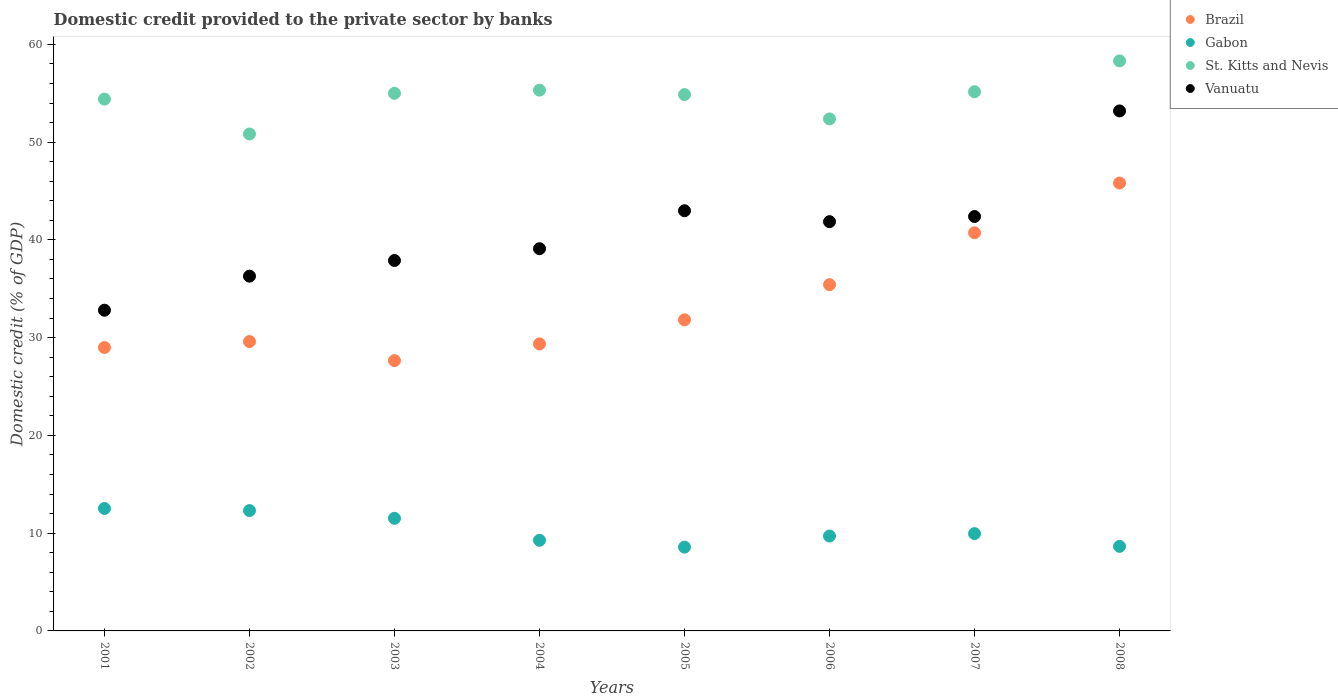How many different coloured dotlines are there?
Your answer should be very brief. 4. What is the domestic credit provided to the private sector by banks in Gabon in 2005?
Offer a very short reply. 8.57. Across all years, what is the maximum domestic credit provided to the private sector by banks in St. Kitts and Nevis?
Your answer should be very brief. 58.31. Across all years, what is the minimum domestic credit provided to the private sector by banks in Vanuatu?
Provide a succinct answer. 32.8. In which year was the domestic credit provided to the private sector by banks in Brazil maximum?
Provide a short and direct response. 2008. What is the total domestic credit provided to the private sector by banks in St. Kitts and Nevis in the graph?
Ensure brevity in your answer.  436.24. What is the difference between the domestic credit provided to the private sector by banks in St. Kitts and Nevis in 2002 and that in 2007?
Give a very brief answer. -4.32. What is the difference between the domestic credit provided to the private sector by banks in Brazil in 2003 and the domestic credit provided to the private sector by banks in St. Kitts and Nevis in 2005?
Your answer should be very brief. -27.21. What is the average domestic credit provided to the private sector by banks in Brazil per year?
Ensure brevity in your answer.  33.67. In the year 2002, what is the difference between the domestic credit provided to the private sector by banks in St. Kitts and Nevis and domestic credit provided to the private sector by banks in Vanuatu?
Provide a succinct answer. 14.54. In how many years, is the domestic credit provided to the private sector by banks in Gabon greater than 2 %?
Your answer should be compact. 8. What is the ratio of the domestic credit provided to the private sector by banks in St. Kitts and Nevis in 2002 to that in 2005?
Offer a very short reply. 0.93. Is the domestic credit provided to the private sector by banks in Vanuatu in 2001 less than that in 2008?
Your answer should be compact. Yes. Is the difference between the domestic credit provided to the private sector by banks in St. Kitts and Nevis in 2005 and 2006 greater than the difference between the domestic credit provided to the private sector by banks in Vanuatu in 2005 and 2006?
Your answer should be compact. Yes. What is the difference between the highest and the second highest domestic credit provided to the private sector by banks in St. Kitts and Nevis?
Make the answer very short. 2.99. What is the difference between the highest and the lowest domestic credit provided to the private sector by banks in Brazil?
Give a very brief answer. 18.16. Is the sum of the domestic credit provided to the private sector by banks in St. Kitts and Nevis in 2005 and 2007 greater than the maximum domestic credit provided to the private sector by banks in Gabon across all years?
Offer a very short reply. Yes. Is the domestic credit provided to the private sector by banks in St. Kitts and Nevis strictly less than the domestic credit provided to the private sector by banks in Gabon over the years?
Your answer should be very brief. No. How many years are there in the graph?
Your answer should be very brief. 8. Does the graph contain grids?
Ensure brevity in your answer.  No. Where does the legend appear in the graph?
Provide a succinct answer. Top right. What is the title of the graph?
Your answer should be compact. Domestic credit provided to the private sector by banks. Does "Senegal" appear as one of the legend labels in the graph?
Your response must be concise. No. What is the label or title of the X-axis?
Provide a succinct answer. Years. What is the label or title of the Y-axis?
Keep it short and to the point. Domestic credit (% of GDP). What is the Domestic credit (% of GDP) in Brazil in 2001?
Keep it short and to the point. 28.99. What is the Domestic credit (% of GDP) of Gabon in 2001?
Your response must be concise. 12.52. What is the Domestic credit (% of GDP) in St. Kitts and Nevis in 2001?
Make the answer very short. 54.4. What is the Domestic credit (% of GDP) of Vanuatu in 2001?
Your answer should be compact. 32.8. What is the Domestic credit (% of GDP) of Brazil in 2002?
Your answer should be compact. 29.6. What is the Domestic credit (% of GDP) of Gabon in 2002?
Your answer should be compact. 12.31. What is the Domestic credit (% of GDP) of St. Kitts and Nevis in 2002?
Offer a very short reply. 50.83. What is the Domestic credit (% of GDP) in Vanuatu in 2002?
Keep it short and to the point. 36.29. What is the Domestic credit (% of GDP) of Brazil in 2003?
Your response must be concise. 27.65. What is the Domestic credit (% of GDP) of Gabon in 2003?
Give a very brief answer. 11.52. What is the Domestic credit (% of GDP) in St. Kitts and Nevis in 2003?
Your response must be concise. 54.99. What is the Domestic credit (% of GDP) in Vanuatu in 2003?
Provide a short and direct response. 37.89. What is the Domestic credit (% of GDP) in Brazil in 2004?
Give a very brief answer. 29.36. What is the Domestic credit (% of GDP) in Gabon in 2004?
Keep it short and to the point. 9.27. What is the Domestic credit (% of GDP) in St. Kitts and Nevis in 2004?
Your response must be concise. 55.32. What is the Domestic credit (% of GDP) of Vanuatu in 2004?
Make the answer very short. 39.1. What is the Domestic credit (% of GDP) of Brazil in 2005?
Keep it short and to the point. 31.82. What is the Domestic credit (% of GDP) of Gabon in 2005?
Your answer should be compact. 8.57. What is the Domestic credit (% of GDP) of St. Kitts and Nevis in 2005?
Provide a short and direct response. 54.86. What is the Domestic credit (% of GDP) of Vanuatu in 2005?
Keep it short and to the point. 42.98. What is the Domestic credit (% of GDP) in Brazil in 2006?
Your response must be concise. 35.42. What is the Domestic credit (% of GDP) of Gabon in 2006?
Give a very brief answer. 9.71. What is the Domestic credit (% of GDP) in St. Kitts and Nevis in 2006?
Your answer should be compact. 52.38. What is the Domestic credit (% of GDP) in Vanuatu in 2006?
Offer a very short reply. 41.86. What is the Domestic credit (% of GDP) in Brazil in 2007?
Give a very brief answer. 40.72. What is the Domestic credit (% of GDP) of Gabon in 2007?
Provide a short and direct response. 9.95. What is the Domestic credit (% of GDP) in St. Kitts and Nevis in 2007?
Make the answer very short. 55.15. What is the Domestic credit (% of GDP) in Vanuatu in 2007?
Provide a short and direct response. 42.39. What is the Domestic credit (% of GDP) of Brazil in 2008?
Your answer should be compact. 45.82. What is the Domestic credit (% of GDP) of Gabon in 2008?
Offer a terse response. 8.65. What is the Domestic credit (% of GDP) of St. Kitts and Nevis in 2008?
Your response must be concise. 58.31. What is the Domestic credit (% of GDP) in Vanuatu in 2008?
Your response must be concise. 53.19. Across all years, what is the maximum Domestic credit (% of GDP) of Brazil?
Provide a short and direct response. 45.82. Across all years, what is the maximum Domestic credit (% of GDP) of Gabon?
Offer a terse response. 12.52. Across all years, what is the maximum Domestic credit (% of GDP) in St. Kitts and Nevis?
Keep it short and to the point. 58.31. Across all years, what is the maximum Domestic credit (% of GDP) of Vanuatu?
Your answer should be compact. 53.19. Across all years, what is the minimum Domestic credit (% of GDP) in Brazil?
Offer a terse response. 27.65. Across all years, what is the minimum Domestic credit (% of GDP) in Gabon?
Keep it short and to the point. 8.57. Across all years, what is the minimum Domestic credit (% of GDP) in St. Kitts and Nevis?
Ensure brevity in your answer.  50.83. Across all years, what is the minimum Domestic credit (% of GDP) in Vanuatu?
Keep it short and to the point. 32.8. What is the total Domestic credit (% of GDP) of Brazil in the graph?
Provide a succinct answer. 269.38. What is the total Domestic credit (% of GDP) in Gabon in the graph?
Provide a short and direct response. 82.5. What is the total Domestic credit (% of GDP) of St. Kitts and Nevis in the graph?
Provide a short and direct response. 436.24. What is the total Domestic credit (% of GDP) of Vanuatu in the graph?
Give a very brief answer. 326.5. What is the difference between the Domestic credit (% of GDP) of Brazil in 2001 and that in 2002?
Your response must be concise. -0.61. What is the difference between the Domestic credit (% of GDP) in Gabon in 2001 and that in 2002?
Make the answer very short. 0.21. What is the difference between the Domestic credit (% of GDP) of St. Kitts and Nevis in 2001 and that in 2002?
Your answer should be very brief. 3.57. What is the difference between the Domestic credit (% of GDP) in Vanuatu in 2001 and that in 2002?
Make the answer very short. -3.48. What is the difference between the Domestic credit (% of GDP) in Brazil in 2001 and that in 2003?
Offer a very short reply. 1.34. What is the difference between the Domestic credit (% of GDP) of Gabon in 2001 and that in 2003?
Ensure brevity in your answer.  1. What is the difference between the Domestic credit (% of GDP) in St. Kitts and Nevis in 2001 and that in 2003?
Ensure brevity in your answer.  -0.6. What is the difference between the Domestic credit (% of GDP) of Vanuatu in 2001 and that in 2003?
Offer a very short reply. -5.08. What is the difference between the Domestic credit (% of GDP) in Brazil in 2001 and that in 2004?
Offer a very short reply. -0.37. What is the difference between the Domestic credit (% of GDP) of Gabon in 2001 and that in 2004?
Your response must be concise. 3.25. What is the difference between the Domestic credit (% of GDP) in St. Kitts and Nevis in 2001 and that in 2004?
Provide a short and direct response. -0.92. What is the difference between the Domestic credit (% of GDP) of Vanuatu in 2001 and that in 2004?
Your answer should be compact. -6.29. What is the difference between the Domestic credit (% of GDP) in Brazil in 2001 and that in 2005?
Your answer should be compact. -2.83. What is the difference between the Domestic credit (% of GDP) in Gabon in 2001 and that in 2005?
Keep it short and to the point. 3.95. What is the difference between the Domestic credit (% of GDP) in St. Kitts and Nevis in 2001 and that in 2005?
Provide a short and direct response. -0.47. What is the difference between the Domestic credit (% of GDP) of Vanuatu in 2001 and that in 2005?
Your response must be concise. -10.18. What is the difference between the Domestic credit (% of GDP) of Brazil in 2001 and that in 2006?
Give a very brief answer. -6.43. What is the difference between the Domestic credit (% of GDP) in Gabon in 2001 and that in 2006?
Provide a succinct answer. 2.81. What is the difference between the Domestic credit (% of GDP) in St. Kitts and Nevis in 2001 and that in 2006?
Keep it short and to the point. 2.02. What is the difference between the Domestic credit (% of GDP) of Vanuatu in 2001 and that in 2006?
Your answer should be very brief. -9.06. What is the difference between the Domestic credit (% of GDP) in Brazil in 2001 and that in 2007?
Offer a terse response. -11.73. What is the difference between the Domestic credit (% of GDP) in Gabon in 2001 and that in 2007?
Your answer should be very brief. 2.57. What is the difference between the Domestic credit (% of GDP) in St. Kitts and Nevis in 2001 and that in 2007?
Ensure brevity in your answer.  -0.75. What is the difference between the Domestic credit (% of GDP) of Vanuatu in 2001 and that in 2007?
Provide a short and direct response. -9.59. What is the difference between the Domestic credit (% of GDP) in Brazil in 2001 and that in 2008?
Your response must be concise. -16.82. What is the difference between the Domestic credit (% of GDP) of Gabon in 2001 and that in 2008?
Your answer should be compact. 3.87. What is the difference between the Domestic credit (% of GDP) of St. Kitts and Nevis in 2001 and that in 2008?
Give a very brief answer. -3.91. What is the difference between the Domestic credit (% of GDP) in Vanuatu in 2001 and that in 2008?
Your response must be concise. -20.38. What is the difference between the Domestic credit (% of GDP) of Brazil in 2002 and that in 2003?
Keep it short and to the point. 1.95. What is the difference between the Domestic credit (% of GDP) in Gabon in 2002 and that in 2003?
Ensure brevity in your answer.  0.79. What is the difference between the Domestic credit (% of GDP) in St. Kitts and Nevis in 2002 and that in 2003?
Keep it short and to the point. -4.16. What is the difference between the Domestic credit (% of GDP) of Vanuatu in 2002 and that in 2003?
Make the answer very short. -1.6. What is the difference between the Domestic credit (% of GDP) in Brazil in 2002 and that in 2004?
Give a very brief answer. 0.24. What is the difference between the Domestic credit (% of GDP) in Gabon in 2002 and that in 2004?
Offer a very short reply. 3.04. What is the difference between the Domestic credit (% of GDP) of St. Kitts and Nevis in 2002 and that in 2004?
Your answer should be very brief. -4.49. What is the difference between the Domestic credit (% of GDP) in Vanuatu in 2002 and that in 2004?
Make the answer very short. -2.81. What is the difference between the Domestic credit (% of GDP) in Brazil in 2002 and that in 2005?
Give a very brief answer. -2.23. What is the difference between the Domestic credit (% of GDP) of Gabon in 2002 and that in 2005?
Your answer should be compact. 3.74. What is the difference between the Domestic credit (% of GDP) of St. Kitts and Nevis in 2002 and that in 2005?
Give a very brief answer. -4.03. What is the difference between the Domestic credit (% of GDP) of Vanuatu in 2002 and that in 2005?
Offer a very short reply. -6.69. What is the difference between the Domestic credit (% of GDP) of Brazil in 2002 and that in 2006?
Provide a succinct answer. -5.82. What is the difference between the Domestic credit (% of GDP) in Gabon in 2002 and that in 2006?
Provide a succinct answer. 2.6. What is the difference between the Domestic credit (% of GDP) of St. Kitts and Nevis in 2002 and that in 2006?
Your answer should be very brief. -1.54. What is the difference between the Domestic credit (% of GDP) in Vanuatu in 2002 and that in 2006?
Your answer should be very brief. -5.57. What is the difference between the Domestic credit (% of GDP) of Brazil in 2002 and that in 2007?
Ensure brevity in your answer.  -11.13. What is the difference between the Domestic credit (% of GDP) in Gabon in 2002 and that in 2007?
Keep it short and to the point. 2.36. What is the difference between the Domestic credit (% of GDP) in St. Kitts and Nevis in 2002 and that in 2007?
Provide a succinct answer. -4.32. What is the difference between the Domestic credit (% of GDP) of Vanuatu in 2002 and that in 2007?
Provide a short and direct response. -6.1. What is the difference between the Domestic credit (% of GDP) in Brazil in 2002 and that in 2008?
Provide a succinct answer. -16.22. What is the difference between the Domestic credit (% of GDP) in Gabon in 2002 and that in 2008?
Give a very brief answer. 3.66. What is the difference between the Domestic credit (% of GDP) in St. Kitts and Nevis in 2002 and that in 2008?
Provide a short and direct response. -7.48. What is the difference between the Domestic credit (% of GDP) of Vanuatu in 2002 and that in 2008?
Provide a short and direct response. -16.9. What is the difference between the Domestic credit (% of GDP) of Brazil in 2003 and that in 2004?
Offer a very short reply. -1.71. What is the difference between the Domestic credit (% of GDP) of Gabon in 2003 and that in 2004?
Make the answer very short. 2.25. What is the difference between the Domestic credit (% of GDP) in St. Kitts and Nevis in 2003 and that in 2004?
Make the answer very short. -0.33. What is the difference between the Domestic credit (% of GDP) of Vanuatu in 2003 and that in 2004?
Your response must be concise. -1.21. What is the difference between the Domestic credit (% of GDP) of Brazil in 2003 and that in 2005?
Your response must be concise. -4.17. What is the difference between the Domestic credit (% of GDP) of Gabon in 2003 and that in 2005?
Make the answer very short. 2.95. What is the difference between the Domestic credit (% of GDP) in St. Kitts and Nevis in 2003 and that in 2005?
Provide a short and direct response. 0.13. What is the difference between the Domestic credit (% of GDP) in Vanuatu in 2003 and that in 2005?
Provide a short and direct response. -5.09. What is the difference between the Domestic credit (% of GDP) of Brazil in 2003 and that in 2006?
Keep it short and to the point. -7.77. What is the difference between the Domestic credit (% of GDP) in Gabon in 2003 and that in 2006?
Your answer should be very brief. 1.81. What is the difference between the Domestic credit (% of GDP) in St. Kitts and Nevis in 2003 and that in 2006?
Provide a succinct answer. 2.62. What is the difference between the Domestic credit (% of GDP) in Vanuatu in 2003 and that in 2006?
Your answer should be compact. -3.97. What is the difference between the Domestic credit (% of GDP) of Brazil in 2003 and that in 2007?
Your answer should be very brief. -13.07. What is the difference between the Domestic credit (% of GDP) in Gabon in 2003 and that in 2007?
Offer a terse response. 1.57. What is the difference between the Domestic credit (% of GDP) of St. Kitts and Nevis in 2003 and that in 2007?
Provide a short and direct response. -0.16. What is the difference between the Domestic credit (% of GDP) of Vanuatu in 2003 and that in 2007?
Your answer should be compact. -4.5. What is the difference between the Domestic credit (% of GDP) in Brazil in 2003 and that in 2008?
Provide a succinct answer. -18.16. What is the difference between the Domestic credit (% of GDP) in Gabon in 2003 and that in 2008?
Give a very brief answer. 2.87. What is the difference between the Domestic credit (% of GDP) of St. Kitts and Nevis in 2003 and that in 2008?
Provide a succinct answer. -3.32. What is the difference between the Domestic credit (% of GDP) in Vanuatu in 2003 and that in 2008?
Provide a short and direct response. -15.3. What is the difference between the Domestic credit (% of GDP) in Brazil in 2004 and that in 2005?
Offer a terse response. -2.46. What is the difference between the Domestic credit (% of GDP) in Gabon in 2004 and that in 2005?
Your answer should be compact. 0.7. What is the difference between the Domestic credit (% of GDP) of St. Kitts and Nevis in 2004 and that in 2005?
Ensure brevity in your answer.  0.45. What is the difference between the Domestic credit (% of GDP) in Vanuatu in 2004 and that in 2005?
Your answer should be compact. -3.88. What is the difference between the Domestic credit (% of GDP) in Brazil in 2004 and that in 2006?
Make the answer very short. -6.06. What is the difference between the Domestic credit (% of GDP) of Gabon in 2004 and that in 2006?
Give a very brief answer. -0.44. What is the difference between the Domestic credit (% of GDP) of St. Kitts and Nevis in 2004 and that in 2006?
Keep it short and to the point. 2.94. What is the difference between the Domestic credit (% of GDP) of Vanuatu in 2004 and that in 2006?
Make the answer very short. -2.77. What is the difference between the Domestic credit (% of GDP) in Brazil in 2004 and that in 2007?
Give a very brief answer. -11.37. What is the difference between the Domestic credit (% of GDP) of Gabon in 2004 and that in 2007?
Your answer should be very brief. -0.68. What is the difference between the Domestic credit (% of GDP) of St. Kitts and Nevis in 2004 and that in 2007?
Ensure brevity in your answer.  0.17. What is the difference between the Domestic credit (% of GDP) in Vanuatu in 2004 and that in 2007?
Provide a short and direct response. -3.29. What is the difference between the Domestic credit (% of GDP) in Brazil in 2004 and that in 2008?
Your answer should be compact. -16.46. What is the difference between the Domestic credit (% of GDP) of Gabon in 2004 and that in 2008?
Make the answer very short. 0.62. What is the difference between the Domestic credit (% of GDP) of St. Kitts and Nevis in 2004 and that in 2008?
Ensure brevity in your answer.  -2.99. What is the difference between the Domestic credit (% of GDP) in Vanuatu in 2004 and that in 2008?
Provide a short and direct response. -14.09. What is the difference between the Domestic credit (% of GDP) in Brazil in 2005 and that in 2006?
Provide a succinct answer. -3.6. What is the difference between the Domestic credit (% of GDP) in Gabon in 2005 and that in 2006?
Give a very brief answer. -1.14. What is the difference between the Domestic credit (% of GDP) in St. Kitts and Nevis in 2005 and that in 2006?
Your answer should be compact. 2.49. What is the difference between the Domestic credit (% of GDP) of Vanuatu in 2005 and that in 2006?
Your answer should be very brief. 1.12. What is the difference between the Domestic credit (% of GDP) in Brazil in 2005 and that in 2007?
Make the answer very short. -8.9. What is the difference between the Domestic credit (% of GDP) in Gabon in 2005 and that in 2007?
Offer a terse response. -1.38. What is the difference between the Domestic credit (% of GDP) of St. Kitts and Nevis in 2005 and that in 2007?
Your answer should be very brief. -0.29. What is the difference between the Domestic credit (% of GDP) of Vanuatu in 2005 and that in 2007?
Make the answer very short. 0.59. What is the difference between the Domestic credit (% of GDP) of Brazil in 2005 and that in 2008?
Give a very brief answer. -13.99. What is the difference between the Domestic credit (% of GDP) in Gabon in 2005 and that in 2008?
Ensure brevity in your answer.  -0.08. What is the difference between the Domestic credit (% of GDP) of St. Kitts and Nevis in 2005 and that in 2008?
Make the answer very short. -3.44. What is the difference between the Domestic credit (% of GDP) in Vanuatu in 2005 and that in 2008?
Make the answer very short. -10.21. What is the difference between the Domestic credit (% of GDP) in Brazil in 2006 and that in 2007?
Your answer should be compact. -5.3. What is the difference between the Domestic credit (% of GDP) of Gabon in 2006 and that in 2007?
Offer a terse response. -0.24. What is the difference between the Domestic credit (% of GDP) of St. Kitts and Nevis in 2006 and that in 2007?
Your answer should be compact. -2.77. What is the difference between the Domestic credit (% of GDP) of Vanuatu in 2006 and that in 2007?
Give a very brief answer. -0.53. What is the difference between the Domestic credit (% of GDP) in Brazil in 2006 and that in 2008?
Offer a very short reply. -10.4. What is the difference between the Domestic credit (% of GDP) of Gabon in 2006 and that in 2008?
Your response must be concise. 1.06. What is the difference between the Domestic credit (% of GDP) in St. Kitts and Nevis in 2006 and that in 2008?
Your answer should be very brief. -5.93. What is the difference between the Domestic credit (% of GDP) in Vanuatu in 2006 and that in 2008?
Make the answer very short. -11.33. What is the difference between the Domestic credit (% of GDP) in Brazil in 2007 and that in 2008?
Provide a short and direct response. -5.09. What is the difference between the Domestic credit (% of GDP) of Gabon in 2007 and that in 2008?
Offer a very short reply. 1.3. What is the difference between the Domestic credit (% of GDP) in St. Kitts and Nevis in 2007 and that in 2008?
Your answer should be very brief. -3.16. What is the difference between the Domestic credit (% of GDP) in Vanuatu in 2007 and that in 2008?
Offer a very short reply. -10.8. What is the difference between the Domestic credit (% of GDP) of Brazil in 2001 and the Domestic credit (% of GDP) of Gabon in 2002?
Offer a very short reply. 16.68. What is the difference between the Domestic credit (% of GDP) of Brazil in 2001 and the Domestic credit (% of GDP) of St. Kitts and Nevis in 2002?
Offer a very short reply. -21.84. What is the difference between the Domestic credit (% of GDP) of Brazil in 2001 and the Domestic credit (% of GDP) of Vanuatu in 2002?
Your response must be concise. -7.3. What is the difference between the Domestic credit (% of GDP) of Gabon in 2001 and the Domestic credit (% of GDP) of St. Kitts and Nevis in 2002?
Provide a short and direct response. -38.31. What is the difference between the Domestic credit (% of GDP) of Gabon in 2001 and the Domestic credit (% of GDP) of Vanuatu in 2002?
Your answer should be very brief. -23.77. What is the difference between the Domestic credit (% of GDP) in St. Kitts and Nevis in 2001 and the Domestic credit (% of GDP) in Vanuatu in 2002?
Provide a short and direct response. 18.11. What is the difference between the Domestic credit (% of GDP) in Brazil in 2001 and the Domestic credit (% of GDP) in Gabon in 2003?
Your answer should be very brief. 17.47. What is the difference between the Domestic credit (% of GDP) of Brazil in 2001 and the Domestic credit (% of GDP) of St. Kitts and Nevis in 2003?
Your response must be concise. -26. What is the difference between the Domestic credit (% of GDP) of Brazil in 2001 and the Domestic credit (% of GDP) of Vanuatu in 2003?
Your response must be concise. -8.9. What is the difference between the Domestic credit (% of GDP) in Gabon in 2001 and the Domestic credit (% of GDP) in St. Kitts and Nevis in 2003?
Your response must be concise. -42.47. What is the difference between the Domestic credit (% of GDP) of Gabon in 2001 and the Domestic credit (% of GDP) of Vanuatu in 2003?
Ensure brevity in your answer.  -25.37. What is the difference between the Domestic credit (% of GDP) of St. Kitts and Nevis in 2001 and the Domestic credit (% of GDP) of Vanuatu in 2003?
Make the answer very short. 16.51. What is the difference between the Domestic credit (% of GDP) of Brazil in 2001 and the Domestic credit (% of GDP) of Gabon in 2004?
Make the answer very short. 19.72. What is the difference between the Domestic credit (% of GDP) of Brazil in 2001 and the Domestic credit (% of GDP) of St. Kitts and Nevis in 2004?
Your response must be concise. -26.33. What is the difference between the Domestic credit (% of GDP) of Brazil in 2001 and the Domestic credit (% of GDP) of Vanuatu in 2004?
Provide a short and direct response. -10.11. What is the difference between the Domestic credit (% of GDP) of Gabon in 2001 and the Domestic credit (% of GDP) of St. Kitts and Nevis in 2004?
Keep it short and to the point. -42.8. What is the difference between the Domestic credit (% of GDP) in Gabon in 2001 and the Domestic credit (% of GDP) in Vanuatu in 2004?
Give a very brief answer. -26.58. What is the difference between the Domestic credit (% of GDP) of St. Kitts and Nevis in 2001 and the Domestic credit (% of GDP) of Vanuatu in 2004?
Ensure brevity in your answer.  15.3. What is the difference between the Domestic credit (% of GDP) of Brazil in 2001 and the Domestic credit (% of GDP) of Gabon in 2005?
Keep it short and to the point. 20.42. What is the difference between the Domestic credit (% of GDP) of Brazil in 2001 and the Domestic credit (% of GDP) of St. Kitts and Nevis in 2005?
Ensure brevity in your answer.  -25.87. What is the difference between the Domestic credit (% of GDP) in Brazil in 2001 and the Domestic credit (% of GDP) in Vanuatu in 2005?
Your answer should be very brief. -13.99. What is the difference between the Domestic credit (% of GDP) in Gabon in 2001 and the Domestic credit (% of GDP) in St. Kitts and Nevis in 2005?
Your answer should be very brief. -42.34. What is the difference between the Domestic credit (% of GDP) of Gabon in 2001 and the Domestic credit (% of GDP) of Vanuatu in 2005?
Your answer should be compact. -30.46. What is the difference between the Domestic credit (% of GDP) of St. Kitts and Nevis in 2001 and the Domestic credit (% of GDP) of Vanuatu in 2005?
Your answer should be very brief. 11.42. What is the difference between the Domestic credit (% of GDP) of Brazil in 2001 and the Domestic credit (% of GDP) of Gabon in 2006?
Offer a very short reply. 19.28. What is the difference between the Domestic credit (% of GDP) of Brazil in 2001 and the Domestic credit (% of GDP) of St. Kitts and Nevis in 2006?
Offer a very short reply. -23.38. What is the difference between the Domestic credit (% of GDP) of Brazil in 2001 and the Domestic credit (% of GDP) of Vanuatu in 2006?
Make the answer very short. -12.87. What is the difference between the Domestic credit (% of GDP) in Gabon in 2001 and the Domestic credit (% of GDP) in St. Kitts and Nevis in 2006?
Your response must be concise. -39.85. What is the difference between the Domestic credit (% of GDP) of Gabon in 2001 and the Domestic credit (% of GDP) of Vanuatu in 2006?
Offer a terse response. -29.34. What is the difference between the Domestic credit (% of GDP) in St. Kitts and Nevis in 2001 and the Domestic credit (% of GDP) in Vanuatu in 2006?
Provide a short and direct response. 12.53. What is the difference between the Domestic credit (% of GDP) of Brazil in 2001 and the Domestic credit (% of GDP) of Gabon in 2007?
Give a very brief answer. 19.04. What is the difference between the Domestic credit (% of GDP) in Brazil in 2001 and the Domestic credit (% of GDP) in St. Kitts and Nevis in 2007?
Give a very brief answer. -26.16. What is the difference between the Domestic credit (% of GDP) in Gabon in 2001 and the Domestic credit (% of GDP) in St. Kitts and Nevis in 2007?
Ensure brevity in your answer.  -42.63. What is the difference between the Domestic credit (% of GDP) in Gabon in 2001 and the Domestic credit (% of GDP) in Vanuatu in 2007?
Offer a very short reply. -29.87. What is the difference between the Domestic credit (% of GDP) in St. Kitts and Nevis in 2001 and the Domestic credit (% of GDP) in Vanuatu in 2007?
Your response must be concise. 12.01. What is the difference between the Domestic credit (% of GDP) of Brazil in 2001 and the Domestic credit (% of GDP) of Gabon in 2008?
Offer a very short reply. 20.34. What is the difference between the Domestic credit (% of GDP) in Brazil in 2001 and the Domestic credit (% of GDP) in St. Kitts and Nevis in 2008?
Give a very brief answer. -29.32. What is the difference between the Domestic credit (% of GDP) in Brazil in 2001 and the Domestic credit (% of GDP) in Vanuatu in 2008?
Offer a very short reply. -24.2. What is the difference between the Domestic credit (% of GDP) of Gabon in 2001 and the Domestic credit (% of GDP) of St. Kitts and Nevis in 2008?
Your response must be concise. -45.79. What is the difference between the Domestic credit (% of GDP) in Gabon in 2001 and the Domestic credit (% of GDP) in Vanuatu in 2008?
Make the answer very short. -40.67. What is the difference between the Domestic credit (% of GDP) in St. Kitts and Nevis in 2001 and the Domestic credit (% of GDP) in Vanuatu in 2008?
Offer a terse response. 1.21. What is the difference between the Domestic credit (% of GDP) of Brazil in 2002 and the Domestic credit (% of GDP) of Gabon in 2003?
Make the answer very short. 18.08. What is the difference between the Domestic credit (% of GDP) in Brazil in 2002 and the Domestic credit (% of GDP) in St. Kitts and Nevis in 2003?
Your answer should be compact. -25.4. What is the difference between the Domestic credit (% of GDP) of Brazil in 2002 and the Domestic credit (% of GDP) of Vanuatu in 2003?
Your response must be concise. -8.29. What is the difference between the Domestic credit (% of GDP) of Gabon in 2002 and the Domestic credit (% of GDP) of St. Kitts and Nevis in 2003?
Your answer should be very brief. -42.68. What is the difference between the Domestic credit (% of GDP) in Gabon in 2002 and the Domestic credit (% of GDP) in Vanuatu in 2003?
Make the answer very short. -25.58. What is the difference between the Domestic credit (% of GDP) in St. Kitts and Nevis in 2002 and the Domestic credit (% of GDP) in Vanuatu in 2003?
Your answer should be very brief. 12.94. What is the difference between the Domestic credit (% of GDP) of Brazil in 2002 and the Domestic credit (% of GDP) of Gabon in 2004?
Provide a succinct answer. 20.33. What is the difference between the Domestic credit (% of GDP) in Brazil in 2002 and the Domestic credit (% of GDP) in St. Kitts and Nevis in 2004?
Give a very brief answer. -25.72. What is the difference between the Domestic credit (% of GDP) of Brazil in 2002 and the Domestic credit (% of GDP) of Vanuatu in 2004?
Provide a succinct answer. -9.5. What is the difference between the Domestic credit (% of GDP) in Gabon in 2002 and the Domestic credit (% of GDP) in St. Kitts and Nevis in 2004?
Offer a terse response. -43.01. What is the difference between the Domestic credit (% of GDP) in Gabon in 2002 and the Domestic credit (% of GDP) in Vanuatu in 2004?
Provide a short and direct response. -26.79. What is the difference between the Domestic credit (% of GDP) of St. Kitts and Nevis in 2002 and the Domestic credit (% of GDP) of Vanuatu in 2004?
Your answer should be very brief. 11.73. What is the difference between the Domestic credit (% of GDP) of Brazil in 2002 and the Domestic credit (% of GDP) of Gabon in 2005?
Make the answer very short. 21.03. What is the difference between the Domestic credit (% of GDP) in Brazil in 2002 and the Domestic credit (% of GDP) in St. Kitts and Nevis in 2005?
Your answer should be compact. -25.27. What is the difference between the Domestic credit (% of GDP) in Brazil in 2002 and the Domestic credit (% of GDP) in Vanuatu in 2005?
Offer a very short reply. -13.38. What is the difference between the Domestic credit (% of GDP) in Gabon in 2002 and the Domestic credit (% of GDP) in St. Kitts and Nevis in 2005?
Your answer should be compact. -42.55. What is the difference between the Domestic credit (% of GDP) in Gabon in 2002 and the Domestic credit (% of GDP) in Vanuatu in 2005?
Your answer should be very brief. -30.67. What is the difference between the Domestic credit (% of GDP) of St. Kitts and Nevis in 2002 and the Domestic credit (% of GDP) of Vanuatu in 2005?
Provide a succinct answer. 7.85. What is the difference between the Domestic credit (% of GDP) of Brazil in 2002 and the Domestic credit (% of GDP) of Gabon in 2006?
Provide a succinct answer. 19.89. What is the difference between the Domestic credit (% of GDP) of Brazil in 2002 and the Domestic credit (% of GDP) of St. Kitts and Nevis in 2006?
Offer a very short reply. -22.78. What is the difference between the Domestic credit (% of GDP) of Brazil in 2002 and the Domestic credit (% of GDP) of Vanuatu in 2006?
Give a very brief answer. -12.27. What is the difference between the Domestic credit (% of GDP) in Gabon in 2002 and the Domestic credit (% of GDP) in St. Kitts and Nevis in 2006?
Keep it short and to the point. -40.07. What is the difference between the Domestic credit (% of GDP) in Gabon in 2002 and the Domestic credit (% of GDP) in Vanuatu in 2006?
Offer a terse response. -29.55. What is the difference between the Domestic credit (% of GDP) in St. Kitts and Nevis in 2002 and the Domestic credit (% of GDP) in Vanuatu in 2006?
Your response must be concise. 8.97. What is the difference between the Domestic credit (% of GDP) in Brazil in 2002 and the Domestic credit (% of GDP) in Gabon in 2007?
Your answer should be very brief. 19.65. What is the difference between the Domestic credit (% of GDP) in Brazil in 2002 and the Domestic credit (% of GDP) in St. Kitts and Nevis in 2007?
Provide a short and direct response. -25.55. What is the difference between the Domestic credit (% of GDP) in Brazil in 2002 and the Domestic credit (% of GDP) in Vanuatu in 2007?
Keep it short and to the point. -12.79. What is the difference between the Domestic credit (% of GDP) in Gabon in 2002 and the Domestic credit (% of GDP) in St. Kitts and Nevis in 2007?
Your answer should be compact. -42.84. What is the difference between the Domestic credit (% of GDP) in Gabon in 2002 and the Domestic credit (% of GDP) in Vanuatu in 2007?
Provide a short and direct response. -30.08. What is the difference between the Domestic credit (% of GDP) of St. Kitts and Nevis in 2002 and the Domestic credit (% of GDP) of Vanuatu in 2007?
Provide a succinct answer. 8.44. What is the difference between the Domestic credit (% of GDP) in Brazil in 2002 and the Domestic credit (% of GDP) in Gabon in 2008?
Provide a short and direct response. 20.95. What is the difference between the Domestic credit (% of GDP) in Brazil in 2002 and the Domestic credit (% of GDP) in St. Kitts and Nevis in 2008?
Your answer should be very brief. -28.71. What is the difference between the Domestic credit (% of GDP) in Brazil in 2002 and the Domestic credit (% of GDP) in Vanuatu in 2008?
Provide a succinct answer. -23.59. What is the difference between the Domestic credit (% of GDP) in Gabon in 2002 and the Domestic credit (% of GDP) in St. Kitts and Nevis in 2008?
Your answer should be compact. -46. What is the difference between the Domestic credit (% of GDP) in Gabon in 2002 and the Domestic credit (% of GDP) in Vanuatu in 2008?
Provide a succinct answer. -40.88. What is the difference between the Domestic credit (% of GDP) of St. Kitts and Nevis in 2002 and the Domestic credit (% of GDP) of Vanuatu in 2008?
Keep it short and to the point. -2.36. What is the difference between the Domestic credit (% of GDP) of Brazil in 2003 and the Domestic credit (% of GDP) of Gabon in 2004?
Your response must be concise. 18.38. What is the difference between the Domestic credit (% of GDP) in Brazil in 2003 and the Domestic credit (% of GDP) in St. Kitts and Nevis in 2004?
Offer a very short reply. -27.67. What is the difference between the Domestic credit (% of GDP) of Brazil in 2003 and the Domestic credit (% of GDP) of Vanuatu in 2004?
Make the answer very short. -11.45. What is the difference between the Domestic credit (% of GDP) of Gabon in 2003 and the Domestic credit (% of GDP) of St. Kitts and Nevis in 2004?
Your response must be concise. -43.8. What is the difference between the Domestic credit (% of GDP) of Gabon in 2003 and the Domestic credit (% of GDP) of Vanuatu in 2004?
Give a very brief answer. -27.58. What is the difference between the Domestic credit (% of GDP) of St. Kitts and Nevis in 2003 and the Domestic credit (% of GDP) of Vanuatu in 2004?
Your answer should be compact. 15.89. What is the difference between the Domestic credit (% of GDP) of Brazil in 2003 and the Domestic credit (% of GDP) of Gabon in 2005?
Offer a very short reply. 19.08. What is the difference between the Domestic credit (% of GDP) in Brazil in 2003 and the Domestic credit (% of GDP) in St. Kitts and Nevis in 2005?
Keep it short and to the point. -27.21. What is the difference between the Domestic credit (% of GDP) of Brazil in 2003 and the Domestic credit (% of GDP) of Vanuatu in 2005?
Provide a short and direct response. -15.33. What is the difference between the Domestic credit (% of GDP) of Gabon in 2003 and the Domestic credit (% of GDP) of St. Kitts and Nevis in 2005?
Offer a very short reply. -43.35. What is the difference between the Domestic credit (% of GDP) in Gabon in 2003 and the Domestic credit (% of GDP) in Vanuatu in 2005?
Offer a terse response. -31.46. What is the difference between the Domestic credit (% of GDP) in St. Kitts and Nevis in 2003 and the Domestic credit (% of GDP) in Vanuatu in 2005?
Offer a very short reply. 12.01. What is the difference between the Domestic credit (% of GDP) of Brazil in 2003 and the Domestic credit (% of GDP) of Gabon in 2006?
Keep it short and to the point. 17.94. What is the difference between the Domestic credit (% of GDP) of Brazil in 2003 and the Domestic credit (% of GDP) of St. Kitts and Nevis in 2006?
Your answer should be very brief. -24.72. What is the difference between the Domestic credit (% of GDP) in Brazil in 2003 and the Domestic credit (% of GDP) in Vanuatu in 2006?
Ensure brevity in your answer.  -14.21. What is the difference between the Domestic credit (% of GDP) in Gabon in 2003 and the Domestic credit (% of GDP) in St. Kitts and Nevis in 2006?
Make the answer very short. -40.86. What is the difference between the Domestic credit (% of GDP) of Gabon in 2003 and the Domestic credit (% of GDP) of Vanuatu in 2006?
Provide a short and direct response. -30.34. What is the difference between the Domestic credit (% of GDP) of St. Kitts and Nevis in 2003 and the Domestic credit (% of GDP) of Vanuatu in 2006?
Keep it short and to the point. 13.13. What is the difference between the Domestic credit (% of GDP) in Brazil in 2003 and the Domestic credit (% of GDP) in Gabon in 2007?
Your response must be concise. 17.7. What is the difference between the Domestic credit (% of GDP) of Brazil in 2003 and the Domestic credit (% of GDP) of St. Kitts and Nevis in 2007?
Offer a terse response. -27.5. What is the difference between the Domestic credit (% of GDP) in Brazil in 2003 and the Domestic credit (% of GDP) in Vanuatu in 2007?
Provide a succinct answer. -14.74. What is the difference between the Domestic credit (% of GDP) of Gabon in 2003 and the Domestic credit (% of GDP) of St. Kitts and Nevis in 2007?
Make the answer very short. -43.63. What is the difference between the Domestic credit (% of GDP) in Gabon in 2003 and the Domestic credit (% of GDP) in Vanuatu in 2007?
Provide a succinct answer. -30.87. What is the difference between the Domestic credit (% of GDP) of St. Kitts and Nevis in 2003 and the Domestic credit (% of GDP) of Vanuatu in 2007?
Provide a short and direct response. 12.6. What is the difference between the Domestic credit (% of GDP) of Brazil in 2003 and the Domestic credit (% of GDP) of Gabon in 2008?
Offer a terse response. 19. What is the difference between the Domestic credit (% of GDP) of Brazil in 2003 and the Domestic credit (% of GDP) of St. Kitts and Nevis in 2008?
Your answer should be compact. -30.66. What is the difference between the Domestic credit (% of GDP) in Brazil in 2003 and the Domestic credit (% of GDP) in Vanuatu in 2008?
Provide a short and direct response. -25.54. What is the difference between the Domestic credit (% of GDP) in Gabon in 2003 and the Domestic credit (% of GDP) in St. Kitts and Nevis in 2008?
Your answer should be very brief. -46.79. What is the difference between the Domestic credit (% of GDP) of Gabon in 2003 and the Domestic credit (% of GDP) of Vanuatu in 2008?
Your answer should be compact. -41.67. What is the difference between the Domestic credit (% of GDP) in St. Kitts and Nevis in 2003 and the Domestic credit (% of GDP) in Vanuatu in 2008?
Offer a terse response. 1.8. What is the difference between the Domestic credit (% of GDP) of Brazil in 2004 and the Domestic credit (% of GDP) of Gabon in 2005?
Ensure brevity in your answer.  20.79. What is the difference between the Domestic credit (% of GDP) in Brazil in 2004 and the Domestic credit (% of GDP) in St. Kitts and Nevis in 2005?
Ensure brevity in your answer.  -25.5. What is the difference between the Domestic credit (% of GDP) in Brazil in 2004 and the Domestic credit (% of GDP) in Vanuatu in 2005?
Offer a terse response. -13.62. What is the difference between the Domestic credit (% of GDP) of Gabon in 2004 and the Domestic credit (% of GDP) of St. Kitts and Nevis in 2005?
Offer a very short reply. -45.59. What is the difference between the Domestic credit (% of GDP) in Gabon in 2004 and the Domestic credit (% of GDP) in Vanuatu in 2005?
Provide a succinct answer. -33.71. What is the difference between the Domestic credit (% of GDP) of St. Kitts and Nevis in 2004 and the Domestic credit (% of GDP) of Vanuatu in 2005?
Offer a very short reply. 12.34. What is the difference between the Domestic credit (% of GDP) of Brazil in 2004 and the Domestic credit (% of GDP) of Gabon in 2006?
Give a very brief answer. 19.65. What is the difference between the Domestic credit (% of GDP) of Brazil in 2004 and the Domestic credit (% of GDP) of St. Kitts and Nevis in 2006?
Offer a very short reply. -23.02. What is the difference between the Domestic credit (% of GDP) of Brazil in 2004 and the Domestic credit (% of GDP) of Vanuatu in 2006?
Give a very brief answer. -12.5. What is the difference between the Domestic credit (% of GDP) of Gabon in 2004 and the Domestic credit (% of GDP) of St. Kitts and Nevis in 2006?
Offer a terse response. -43.11. What is the difference between the Domestic credit (% of GDP) of Gabon in 2004 and the Domestic credit (% of GDP) of Vanuatu in 2006?
Offer a terse response. -32.59. What is the difference between the Domestic credit (% of GDP) in St. Kitts and Nevis in 2004 and the Domestic credit (% of GDP) in Vanuatu in 2006?
Provide a succinct answer. 13.46. What is the difference between the Domestic credit (% of GDP) in Brazil in 2004 and the Domestic credit (% of GDP) in Gabon in 2007?
Keep it short and to the point. 19.41. What is the difference between the Domestic credit (% of GDP) in Brazil in 2004 and the Domestic credit (% of GDP) in St. Kitts and Nevis in 2007?
Ensure brevity in your answer.  -25.79. What is the difference between the Domestic credit (% of GDP) in Brazil in 2004 and the Domestic credit (% of GDP) in Vanuatu in 2007?
Provide a short and direct response. -13.03. What is the difference between the Domestic credit (% of GDP) in Gabon in 2004 and the Domestic credit (% of GDP) in St. Kitts and Nevis in 2007?
Give a very brief answer. -45.88. What is the difference between the Domestic credit (% of GDP) in Gabon in 2004 and the Domestic credit (% of GDP) in Vanuatu in 2007?
Your answer should be compact. -33.12. What is the difference between the Domestic credit (% of GDP) in St. Kitts and Nevis in 2004 and the Domestic credit (% of GDP) in Vanuatu in 2007?
Keep it short and to the point. 12.93. What is the difference between the Domestic credit (% of GDP) of Brazil in 2004 and the Domestic credit (% of GDP) of Gabon in 2008?
Your answer should be compact. 20.71. What is the difference between the Domestic credit (% of GDP) of Brazil in 2004 and the Domestic credit (% of GDP) of St. Kitts and Nevis in 2008?
Keep it short and to the point. -28.95. What is the difference between the Domestic credit (% of GDP) of Brazil in 2004 and the Domestic credit (% of GDP) of Vanuatu in 2008?
Offer a terse response. -23.83. What is the difference between the Domestic credit (% of GDP) of Gabon in 2004 and the Domestic credit (% of GDP) of St. Kitts and Nevis in 2008?
Give a very brief answer. -49.04. What is the difference between the Domestic credit (% of GDP) in Gabon in 2004 and the Domestic credit (% of GDP) in Vanuatu in 2008?
Your response must be concise. -43.92. What is the difference between the Domestic credit (% of GDP) in St. Kitts and Nevis in 2004 and the Domestic credit (% of GDP) in Vanuatu in 2008?
Offer a very short reply. 2.13. What is the difference between the Domestic credit (% of GDP) of Brazil in 2005 and the Domestic credit (% of GDP) of Gabon in 2006?
Offer a terse response. 22.12. What is the difference between the Domestic credit (% of GDP) of Brazil in 2005 and the Domestic credit (% of GDP) of St. Kitts and Nevis in 2006?
Give a very brief answer. -20.55. What is the difference between the Domestic credit (% of GDP) in Brazil in 2005 and the Domestic credit (% of GDP) in Vanuatu in 2006?
Offer a terse response. -10.04. What is the difference between the Domestic credit (% of GDP) of Gabon in 2005 and the Domestic credit (% of GDP) of St. Kitts and Nevis in 2006?
Give a very brief answer. -43.81. What is the difference between the Domestic credit (% of GDP) of Gabon in 2005 and the Domestic credit (% of GDP) of Vanuatu in 2006?
Offer a terse response. -33.29. What is the difference between the Domestic credit (% of GDP) of St. Kitts and Nevis in 2005 and the Domestic credit (% of GDP) of Vanuatu in 2006?
Ensure brevity in your answer.  13. What is the difference between the Domestic credit (% of GDP) in Brazil in 2005 and the Domestic credit (% of GDP) in Gabon in 2007?
Your answer should be compact. 21.87. What is the difference between the Domestic credit (% of GDP) in Brazil in 2005 and the Domestic credit (% of GDP) in St. Kitts and Nevis in 2007?
Your answer should be compact. -23.33. What is the difference between the Domestic credit (% of GDP) in Brazil in 2005 and the Domestic credit (% of GDP) in Vanuatu in 2007?
Your answer should be compact. -10.57. What is the difference between the Domestic credit (% of GDP) in Gabon in 2005 and the Domestic credit (% of GDP) in St. Kitts and Nevis in 2007?
Your answer should be very brief. -46.58. What is the difference between the Domestic credit (% of GDP) in Gabon in 2005 and the Domestic credit (% of GDP) in Vanuatu in 2007?
Offer a terse response. -33.82. What is the difference between the Domestic credit (% of GDP) of St. Kitts and Nevis in 2005 and the Domestic credit (% of GDP) of Vanuatu in 2007?
Give a very brief answer. 12.47. What is the difference between the Domestic credit (% of GDP) in Brazil in 2005 and the Domestic credit (% of GDP) in Gabon in 2008?
Offer a terse response. 23.17. What is the difference between the Domestic credit (% of GDP) in Brazil in 2005 and the Domestic credit (% of GDP) in St. Kitts and Nevis in 2008?
Ensure brevity in your answer.  -26.49. What is the difference between the Domestic credit (% of GDP) in Brazil in 2005 and the Domestic credit (% of GDP) in Vanuatu in 2008?
Your response must be concise. -21.37. What is the difference between the Domestic credit (% of GDP) in Gabon in 2005 and the Domestic credit (% of GDP) in St. Kitts and Nevis in 2008?
Provide a succinct answer. -49.74. What is the difference between the Domestic credit (% of GDP) in Gabon in 2005 and the Domestic credit (% of GDP) in Vanuatu in 2008?
Make the answer very short. -44.62. What is the difference between the Domestic credit (% of GDP) of St. Kitts and Nevis in 2005 and the Domestic credit (% of GDP) of Vanuatu in 2008?
Your answer should be compact. 1.67. What is the difference between the Domestic credit (% of GDP) in Brazil in 2006 and the Domestic credit (% of GDP) in Gabon in 2007?
Your answer should be very brief. 25.47. What is the difference between the Domestic credit (% of GDP) of Brazil in 2006 and the Domestic credit (% of GDP) of St. Kitts and Nevis in 2007?
Your response must be concise. -19.73. What is the difference between the Domestic credit (% of GDP) in Brazil in 2006 and the Domestic credit (% of GDP) in Vanuatu in 2007?
Your answer should be compact. -6.97. What is the difference between the Domestic credit (% of GDP) in Gabon in 2006 and the Domestic credit (% of GDP) in St. Kitts and Nevis in 2007?
Your answer should be very brief. -45.44. What is the difference between the Domestic credit (% of GDP) of Gabon in 2006 and the Domestic credit (% of GDP) of Vanuatu in 2007?
Offer a terse response. -32.68. What is the difference between the Domestic credit (% of GDP) of St. Kitts and Nevis in 2006 and the Domestic credit (% of GDP) of Vanuatu in 2007?
Offer a terse response. 9.98. What is the difference between the Domestic credit (% of GDP) of Brazil in 2006 and the Domestic credit (% of GDP) of Gabon in 2008?
Make the answer very short. 26.77. What is the difference between the Domestic credit (% of GDP) of Brazil in 2006 and the Domestic credit (% of GDP) of St. Kitts and Nevis in 2008?
Your answer should be very brief. -22.89. What is the difference between the Domestic credit (% of GDP) of Brazil in 2006 and the Domestic credit (% of GDP) of Vanuatu in 2008?
Offer a terse response. -17.77. What is the difference between the Domestic credit (% of GDP) of Gabon in 2006 and the Domestic credit (% of GDP) of St. Kitts and Nevis in 2008?
Offer a terse response. -48.6. What is the difference between the Domestic credit (% of GDP) in Gabon in 2006 and the Domestic credit (% of GDP) in Vanuatu in 2008?
Provide a short and direct response. -43.48. What is the difference between the Domestic credit (% of GDP) in St. Kitts and Nevis in 2006 and the Domestic credit (% of GDP) in Vanuatu in 2008?
Your response must be concise. -0.81. What is the difference between the Domestic credit (% of GDP) of Brazil in 2007 and the Domestic credit (% of GDP) of Gabon in 2008?
Offer a very short reply. 32.07. What is the difference between the Domestic credit (% of GDP) of Brazil in 2007 and the Domestic credit (% of GDP) of St. Kitts and Nevis in 2008?
Your answer should be compact. -17.58. What is the difference between the Domestic credit (% of GDP) in Brazil in 2007 and the Domestic credit (% of GDP) in Vanuatu in 2008?
Keep it short and to the point. -12.46. What is the difference between the Domestic credit (% of GDP) in Gabon in 2007 and the Domestic credit (% of GDP) in St. Kitts and Nevis in 2008?
Your answer should be compact. -48.36. What is the difference between the Domestic credit (% of GDP) of Gabon in 2007 and the Domestic credit (% of GDP) of Vanuatu in 2008?
Provide a short and direct response. -43.24. What is the difference between the Domestic credit (% of GDP) in St. Kitts and Nevis in 2007 and the Domestic credit (% of GDP) in Vanuatu in 2008?
Ensure brevity in your answer.  1.96. What is the average Domestic credit (% of GDP) in Brazil per year?
Offer a terse response. 33.67. What is the average Domestic credit (% of GDP) in Gabon per year?
Your answer should be very brief. 10.31. What is the average Domestic credit (% of GDP) of St. Kitts and Nevis per year?
Ensure brevity in your answer.  54.53. What is the average Domestic credit (% of GDP) in Vanuatu per year?
Give a very brief answer. 40.81. In the year 2001, what is the difference between the Domestic credit (% of GDP) of Brazil and Domestic credit (% of GDP) of Gabon?
Give a very brief answer. 16.47. In the year 2001, what is the difference between the Domestic credit (% of GDP) of Brazil and Domestic credit (% of GDP) of St. Kitts and Nevis?
Offer a very short reply. -25.41. In the year 2001, what is the difference between the Domestic credit (% of GDP) in Brazil and Domestic credit (% of GDP) in Vanuatu?
Ensure brevity in your answer.  -3.81. In the year 2001, what is the difference between the Domestic credit (% of GDP) in Gabon and Domestic credit (% of GDP) in St. Kitts and Nevis?
Ensure brevity in your answer.  -41.88. In the year 2001, what is the difference between the Domestic credit (% of GDP) of Gabon and Domestic credit (% of GDP) of Vanuatu?
Provide a short and direct response. -20.28. In the year 2001, what is the difference between the Domestic credit (% of GDP) in St. Kitts and Nevis and Domestic credit (% of GDP) in Vanuatu?
Provide a succinct answer. 21.59. In the year 2002, what is the difference between the Domestic credit (% of GDP) in Brazil and Domestic credit (% of GDP) in Gabon?
Make the answer very short. 17.29. In the year 2002, what is the difference between the Domestic credit (% of GDP) of Brazil and Domestic credit (% of GDP) of St. Kitts and Nevis?
Your answer should be compact. -21.23. In the year 2002, what is the difference between the Domestic credit (% of GDP) of Brazil and Domestic credit (% of GDP) of Vanuatu?
Your response must be concise. -6.69. In the year 2002, what is the difference between the Domestic credit (% of GDP) in Gabon and Domestic credit (% of GDP) in St. Kitts and Nevis?
Your answer should be compact. -38.52. In the year 2002, what is the difference between the Domestic credit (% of GDP) in Gabon and Domestic credit (% of GDP) in Vanuatu?
Give a very brief answer. -23.98. In the year 2002, what is the difference between the Domestic credit (% of GDP) of St. Kitts and Nevis and Domestic credit (% of GDP) of Vanuatu?
Provide a succinct answer. 14.54. In the year 2003, what is the difference between the Domestic credit (% of GDP) in Brazil and Domestic credit (% of GDP) in Gabon?
Your answer should be very brief. 16.13. In the year 2003, what is the difference between the Domestic credit (% of GDP) in Brazil and Domestic credit (% of GDP) in St. Kitts and Nevis?
Your response must be concise. -27.34. In the year 2003, what is the difference between the Domestic credit (% of GDP) of Brazil and Domestic credit (% of GDP) of Vanuatu?
Offer a terse response. -10.24. In the year 2003, what is the difference between the Domestic credit (% of GDP) in Gabon and Domestic credit (% of GDP) in St. Kitts and Nevis?
Make the answer very short. -43.47. In the year 2003, what is the difference between the Domestic credit (% of GDP) in Gabon and Domestic credit (% of GDP) in Vanuatu?
Make the answer very short. -26.37. In the year 2003, what is the difference between the Domestic credit (% of GDP) in St. Kitts and Nevis and Domestic credit (% of GDP) in Vanuatu?
Your answer should be very brief. 17.1. In the year 2004, what is the difference between the Domestic credit (% of GDP) of Brazil and Domestic credit (% of GDP) of Gabon?
Offer a very short reply. 20.09. In the year 2004, what is the difference between the Domestic credit (% of GDP) of Brazil and Domestic credit (% of GDP) of St. Kitts and Nevis?
Your answer should be very brief. -25.96. In the year 2004, what is the difference between the Domestic credit (% of GDP) in Brazil and Domestic credit (% of GDP) in Vanuatu?
Your answer should be very brief. -9.74. In the year 2004, what is the difference between the Domestic credit (% of GDP) of Gabon and Domestic credit (% of GDP) of St. Kitts and Nevis?
Offer a very short reply. -46.05. In the year 2004, what is the difference between the Domestic credit (% of GDP) in Gabon and Domestic credit (% of GDP) in Vanuatu?
Offer a terse response. -29.83. In the year 2004, what is the difference between the Domestic credit (% of GDP) of St. Kitts and Nevis and Domestic credit (% of GDP) of Vanuatu?
Your answer should be compact. 16.22. In the year 2005, what is the difference between the Domestic credit (% of GDP) of Brazil and Domestic credit (% of GDP) of Gabon?
Make the answer very short. 23.25. In the year 2005, what is the difference between the Domestic credit (% of GDP) in Brazil and Domestic credit (% of GDP) in St. Kitts and Nevis?
Your answer should be very brief. -23.04. In the year 2005, what is the difference between the Domestic credit (% of GDP) in Brazil and Domestic credit (% of GDP) in Vanuatu?
Give a very brief answer. -11.16. In the year 2005, what is the difference between the Domestic credit (% of GDP) in Gabon and Domestic credit (% of GDP) in St. Kitts and Nevis?
Your answer should be very brief. -46.29. In the year 2005, what is the difference between the Domestic credit (% of GDP) of Gabon and Domestic credit (% of GDP) of Vanuatu?
Provide a short and direct response. -34.41. In the year 2005, what is the difference between the Domestic credit (% of GDP) in St. Kitts and Nevis and Domestic credit (% of GDP) in Vanuatu?
Offer a very short reply. 11.88. In the year 2006, what is the difference between the Domestic credit (% of GDP) of Brazil and Domestic credit (% of GDP) of Gabon?
Provide a succinct answer. 25.71. In the year 2006, what is the difference between the Domestic credit (% of GDP) in Brazil and Domestic credit (% of GDP) in St. Kitts and Nevis?
Offer a very short reply. -16.96. In the year 2006, what is the difference between the Domestic credit (% of GDP) of Brazil and Domestic credit (% of GDP) of Vanuatu?
Ensure brevity in your answer.  -6.44. In the year 2006, what is the difference between the Domestic credit (% of GDP) in Gabon and Domestic credit (% of GDP) in St. Kitts and Nevis?
Make the answer very short. -42.67. In the year 2006, what is the difference between the Domestic credit (% of GDP) of Gabon and Domestic credit (% of GDP) of Vanuatu?
Give a very brief answer. -32.15. In the year 2006, what is the difference between the Domestic credit (% of GDP) in St. Kitts and Nevis and Domestic credit (% of GDP) in Vanuatu?
Make the answer very short. 10.51. In the year 2007, what is the difference between the Domestic credit (% of GDP) in Brazil and Domestic credit (% of GDP) in Gabon?
Make the answer very short. 30.77. In the year 2007, what is the difference between the Domestic credit (% of GDP) of Brazil and Domestic credit (% of GDP) of St. Kitts and Nevis?
Provide a succinct answer. -14.43. In the year 2007, what is the difference between the Domestic credit (% of GDP) in Brazil and Domestic credit (% of GDP) in Vanuatu?
Keep it short and to the point. -1.67. In the year 2007, what is the difference between the Domestic credit (% of GDP) in Gabon and Domestic credit (% of GDP) in St. Kitts and Nevis?
Keep it short and to the point. -45.2. In the year 2007, what is the difference between the Domestic credit (% of GDP) in Gabon and Domestic credit (% of GDP) in Vanuatu?
Offer a terse response. -32.44. In the year 2007, what is the difference between the Domestic credit (% of GDP) of St. Kitts and Nevis and Domestic credit (% of GDP) of Vanuatu?
Your answer should be very brief. 12.76. In the year 2008, what is the difference between the Domestic credit (% of GDP) in Brazil and Domestic credit (% of GDP) in Gabon?
Provide a succinct answer. 37.16. In the year 2008, what is the difference between the Domestic credit (% of GDP) in Brazil and Domestic credit (% of GDP) in St. Kitts and Nevis?
Offer a terse response. -12.49. In the year 2008, what is the difference between the Domestic credit (% of GDP) of Brazil and Domestic credit (% of GDP) of Vanuatu?
Your answer should be compact. -7.37. In the year 2008, what is the difference between the Domestic credit (% of GDP) of Gabon and Domestic credit (% of GDP) of St. Kitts and Nevis?
Keep it short and to the point. -49.66. In the year 2008, what is the difference between the Domestic credit (% of GDP) in Gabon and Domestic credit (% of GDP) in Vanuatu?
Provide a short and direct response. -44.54. In the year 2008, what is the difference between the Domestic credit (% of GDP) in St. Kitts and Nevis and Domestic credit (% of GDP) in Vanuatu?
Give a very brief answer. 5.12. What is the ratio of the Domestic credit (% of GDP) of Brazil in 2001 to that in 2002?
Ensure brevity in your answer.  0.98. What is the ratio of the Domestic credit (% of GDP) of Gabon in 2001 to that in 2002?
Give a very brief answer. 1.02. What is the ratio of the Domestic credit (% of GDP) in St. Kitts and Nevis in 2001 to that in 2002?
Keep it short and to the point. 1.07. What is the ratio of the Domestic credit (% of GDP) in Vanuatu in 2001 to that in 2002?
Keep it short and to the point. 0.9. What is the ratio of the Domestic credit (% of GDP) in Brazil in 2001 to that in 2003?
Your response must be concise. 1.05. What is the ratio of the Domestic credit (% of GDP) in Gabon in 2001 to that in 2003?
Your answer should be compact. 1.09. What is the ratio of the Domestic credit (% of GDP) of Vanuatu in 2001 to that in 2003?
Ensure brevity in your answer.  0.87. What is the ratio of the Domestic credit (% of GDP) of Brazil in 2001 to that in 2004?
Ensure brevity in your answer.  0.99. What is the ratio of the Domestic credit (% of GDP) in Gabon in 2001 to that in 2004?
Offer a very short reply. 1.35. What is the ratio of the Domestic credit (% of GDP) of St. Kitts and Nevis in 2001 to that in 2004?
Your answer should be very brief. 0.98. What is the ratio of the Domestic credit (% of GDP) in Vanuatu in 2001 to that in 2004?
Give a very brief answer. 0.84. What is the ratio of the Domestic credit (% of GDP) in Brazil in 2001 to that in 2005?
Ensure brevity in your answer.  0.91. What is the ratio of the Domestic credit (% of GDP) of Gabon in 2001 to that in 2005?
Ensure brevity in your answer.  1.46. What is the ratio of the Domestic credit (% of GDP) of Vanuatu in 2001 to that in 2005?
Give a very brief answer. 0.76. What is the ratio of the Domestic credit (% of GDP) of Brazil in 2001 to that in 2006?
Provide a short and direct response. 0.82. What is the ratio of the Domestic credit (% of GDP) in Gabon in 2001 to that in 2006?
Your answer should be very brief. 1.29. What is the ratio of the Domestic credit (% of GDP) in St. Kitts and Nevis in 2001 to that in 2006?
Provide a short and direct response. 1.04. What is the ratio of the Domestic credit (% of GDP) of Vanuatu in 2001 to that in 2006?
Provide a short and direct response. 0.78. What is the ratio of the Domestic credit (% of GDP) in Brazil in 2001 to that in 2007?
Your response must be concise. 0.71. What is the ratio of the Domestic credit (% of GDP) in Gabon in 2001 to that in 2007?
Give a very brief answer. 1.26. What is the ratio of the Domestic credit (% of GDP) in St. Kitts and Nevis in 2001 to that in 2007?
Provide a short and direct response. 0.99. What is the ratio of the Domestic credit (% of GDP) in Vanuatu in 2001 to that in 2007?
Keep it short and to the point. 0.77. What is the ratio of the Domestic credit (% of GDP) of Brazil in 2001 to that in 2008?
Make the answer very short. 0.63. What is the ratio of the Domestic credit (% of GDP) in Gabon in 2001 to that in 2008?
Your answer should be very brief. 1.45. What is the ratio of the Domestic credit (% of GDP) of St. Kitts and Nevis in 2001 to that in 2008?
Keep it short and to the point. 0.93. What is the ratio of the Domestic credit (% of GDP) of Vanuatu in 2001 to that in 2008?
Ensure brevity in your answer.  0.62. What is the ratio of the Domestic credit (% of GDP) of Brazil in 2002 to that in 2003?
Offer a very short reply. 1.07. What is the ratio of the Domestic credit (% of GDP) of Gabon in 2002 to that in 2003?
Your response must be concise. 1.07. What is the ratio of the Domestic credit (% of GDP) of St. Kitts and Nevis in 2002 to that in 2003?
Make the answer very short. 0.92. What is the ratio of the Domestic credit (% of GDP) of Vanuatu in 2002 to that in 2003?
Give a very brief answer. 0.96. What is the ratio of the Domestic credit (% of GDP) in Gabon in 2002 to that in 2004?
Offer a very short reply. 1.33. What is the ratio of the Domestic credit (% of GDP) of St. Kitts and Nevis in 2002 to that in 2004?
Ensure brevity in your answer.  0.92. What is the ratio of the Domestic credit (% of GDP) of Vanuatu in 2002 to that in 2004?
Ensure brevity in your answer.  0.93. What is the ratio of the Domestic credit (% of GDP) of Brazil in 2002 to that in 2005?
Your response must be concise. 0.93. What is the ratio of the Domestic credit (% of GDP) in Gabon in 2002 to that in 2005?
Provide a succinct answer. 1.44. What is the ratio of the Domestic credit (% of GDP) in St. Kitts and Nevis in 2002 to that in 2005?
Provide a short and direct response. 0.93. What is the ratio of the Domestic credit (% of GDP) in Vanuatu in 2002 to that in 2005?
Give a very brief answer. 0.84. What is the ratio of the Domestic credit (% of GDP) in Brazil in 2002 to that in 2006?
Your answer should be very brief. 0.84. What is the ratio of the Domestic credit (% of GDP) in Gabon in 2002 to that in 2006?
Offer a very short reply. 1.27. What is the ratio of the Domestic credit (% of GDP) in St. Kitts and Nevis in 2002 to that in 2006?
Keep it short and to the point. 0.97. What is the ratio of the Domestic credit (% of GDP) of Vanuatu in 2002 to that in 2006?
Your response must be concise. 0.87. What is the ratio of the Domestic credit (% of GDP) in Brazil in 2002 to that in 2007?
Offer a very short reply. 0.73. What is the ratio of the Domestic credit (% of GDP) in Gabon in 2002 to that in 2007?
Your response must be concise. 1.24. What is the ratio of the Domestic credit (% of GDP) in St. Kitts and Nevis in 2002 to that in 2007?
Keep it short and to the point. 0.92. What is the ratio of the Domestic credit (% of GDP) in Vanuatu in 2002 to that in 2007?
Ensure brevity in your answer.  0.86. What is the ratio of the Domestic credit (% of GDP) of Brazil in 2002 to that in 2008?
Your response must be concise. 0.65. What is the ratio of the Domestic credit (% of GDP) in Gabon in 2002 to that in 2008?
Give a very brief answer. 1.42. What is the ratio of the Domestic credit (% of GDP) of St. Kitts and Nevis in 2002 to that in 2008?
Make the answer very short. 0.87. What is the ratio of the Domestic credit (% of GDP) of Vanuatu in 2002 to that in 2008?
Offer a terse response. 0.68. What is the ratio of the Domestic credit (% of GDP) of Brazil in 2003 to that in 2004?
Provide a succinct answer. 0.94. What is the ratio of the Domestic credit (% of GDP) of Gabon in 2003 to that in 2004?
Offer a very short reply. 1.24. What is the ratio of the Domestic credit (% of GDP) of Vanuatu in 2003 to that in 2004?
Provide a short and direct response. 0.97. What is the ratio of the Domestic credit (% of GDP) of Brazil in 2003 to that in 2005?
Your answer should be compact. 0.87. What is the ratio of the Domestic credit (% of GDP) in Gabon in 2003 to that in 2005?
Keep it short and to the point. 1.34. What is the ratio of the Domestic credit (% of GDP) in Vanuatu in 2003 to that in 2005?
Provide a succinct answer. 0.88. What is the ratio of the Domestic credit (% of GDP) of Brazil in 2003 to that in 2006?
Your response must be concise. 0.78. What is the ratio of the Domestic credit (% of GDP) of Gabon in 2003 to that in 2006?
Provide a succinct answer. 1.19. What is the ratio of the Domestic credit (% of GDP) in Vanuatu in 2003 to that in 2006?
Offer a very short reply. 0.91. What is the ratio of the Domestic credit (% of GDP) of Brazil in 2003 to that in 2007?
Ensure brevity in your answer.  0.68. What is the ratio of the Domestic credit (% of GDP) in Gabon in 2003 to that in 2007?
Keep it short and to the point. 1.16. What is the ratio of the Domestic credit (% of GDP) in St. Kitts and Nevis in 2003 to that in 2007?
Your answer should be very brief. 1. What is the ratio of the Domestic credit (% of GDP) of Vanuatu in 2003 to that in 2007?
Provide a short and direct response. 0.89. What is the ratio of the Domestic credit (% of GDP) of Brazil in 2003 to that in 2008?
Your response must be concise. 0.6. What is the ratio of the Domestic credit (% of GDP) in Gabon in 2003 to that in 2008?
Make the answer very short. 1.33. What is the ratio of the Domestic credit (% of GDP) of St. Kitts and Nevis in 2003 to that in 2008?
Your response must be concise. 0.94. What is the ratio of the Domestic credit (% of GDP) of Vanuatu in 2003 to that in 2008?
Make the answer very short. 0.71. What is the ratio of the Domestic credit (% of GDP) in Brazil in 2004 to that in 2005?
Your response must be concise. 0.92. What is the ratio of the Domestic credit (% of GDP) of Gabon in 2004 to that in 2005?
Your answer should be compact. 1.08. What is the ratio of the Domestic credit (% of GDP) of St. Kitts and Nevis in 2004 to that in 2005?
Make the answer very short. 1.01. What is the ratio of the Domestic credit (% of GDP) of Vanuatu in 2004 to that in 2005?
Your response must be concise. 0.91. What is the ratio of the Domestic credit (% of GDP) in Brazil in 2004 to that in 2006?
Your answer should be very brief. 0.83. What is the ratio of the Domestic credit (% of GDP) in Gabon in 2004 to that in 2006?
Provide a short and direct response. 0.95. What is the ratio of the Domestic credit (% of GDP) in St. Kitts and Nevis in 2004 to that in 2006?
Offer a very short reply. 1.06. What is the ratio of the Domestic credit (% of GDP) of Vanuatu in 2004 to that in 2006?
Your answer should be very brief. 0.93. What is the ratio of the Domestic credit (% of GDP) of Brazil in 2004 to that in 2007?
Offer a very short reply. 0.72. What is the ratio of the Domestic credit (% of GDP) in Gabon in 2004 to that in 2007?
Keep it short and to the point. 0.93. What is the ratio of the Domestic credit (% of GDP) in St. Kitts and Nevis in 2004 to that in 2007?
Provide a short and direct response. 1. What is the ratio of the Domestic credit (% of GDP) of Vanuatu in 2004 to that in 2007?
Ensure brevity in your answer.  0.92. What is the ratio of the Domestic credit (% of GDP) in Brazil in 2004 to that in 2008?
Your response must be concise. 0.64. What is the ratio of the Domestic credit (% of GDP) in Gabon in 2004 to that in 2008?
Your response must be concise. 1.07. What is the ratio of the Domestic credit (% of GDP) in St. Kitts and Nevis in 2004 to that in 2008?
Ensure brevity in your answer.  0.95. What is the ratio of the Domestic credit (% of GDP) of Vanuatu in 2004 to that in 2008?
Your response must be concise. 0.74. What is the ratio of the Domestic credit (% of GDP) in Brazil in 2005 to that in 2006?
Make the answer very short. 0.9. What is the ratio of the Domestic credit (% of GDP) in Gabon in 2005 to that in 2006?
Provide a succinct answer. 0.88. What is the ratio of the Domestic credit (% of GDP) of St. Kitts and Nevis in 2005 to that in 2006?
Offer a very short reply. 1.05. What is the ratio of the Domestic credit (% of GDP) in Vanuatu in 2005 to that in 2006?
Ensure brevity in your answer.  1.03. What is the ratio of the Domestic credit (% of GDP) of Brazil in 2005 to that in 2007?
Your response must be concise. 0.78. What is the ratio of the Domestic credit (% of GDP) in Gabon in 2005 to that in 2007?
Give a very brief answer. 0.86. What is the ratio of the Domestic credit (% of GDP) in St. Kitts and Nevis in 2005 to that in 2007?
Offer a very short reply. 0.99. What is the ratio of the Domestic credit (% of GDP) of Vanuatu in 2005 to that in 2007?
Provide a succinct answer. 1.01. What is the ratio of the Domestic credit (% of GDP) of Brazil in 2005 to that in 2008?
Give a very brief answer. 0.69. What is the ratio of the Domestic credit (% of GDP) in St. Kitts and Nevis in 2005 to that in 2008?
Your response must be concise. 0.94. What is the ratio of the Domestic credit (% of GDP) in Vanuatu in 2005 to that in 2008?
Keep it short and to the point. 0.81. What is the ratio of the Domestic credit (% of GDP) in Brazil in 2006 to that in 2007?
Provide a succinct answer. 0.87. What is the ratio of the Domestic credit (% of GDP) in Gabon in 2006 to that in 2007?
Your response must be concise. 0.98. What is the ratio of the Domestic credit (% of GDP) of St. Kitts and Nevis in 2006 to that in 2007?
Your answer should be very brief. 0.95. What is the ratio of the Domestic credit (% of GDP) of Vanuatu in 2006 to that in 2007?
Provide a short and direct response. 0.99. What is the ratio of the Domestic credit (% of GDP) of Brazil in 2006 to that in 2008?
Offer a very short reply. 0.77. What is the ratio of the Domestic credit (% of GDP) in Gabon in 2006 to that in 2008?
Provide a succinct answer. 1.12. What is the ratio of the Domestic credit (% of GDP) of St. Kitts and Nevis in 2006 to that in 2008?
Keep it short and to the point. 0.9. What is the ratio of the Domestic credit (% of GDP) in Vanuatu in 2006 to that in 2008?
Provide a short and direct response. 0.79. What is the ratio of the Domestic credit (% of GDP) of Brazil in 2007 to that in 2008?
Give a very brief answer. 0.89. What is the ratio of the Domestic credit (% of GDP) in Gabon in 2007 to that in 2008?
Make the answer very short. 1.15. What is the ratio of the Domestic credit (% of GDP) in St. Kitts and Nevis in 2007 to that in 2008?
Your answer should be very brief. 0.95. What is the ratio of the Domestic credit (% of GDP) in Vanuatu in 2007 to that in 2008?
Offer a very short reply. 0.8. What is the difference between the highest and the second highest Domestic credit (% of GDP) of Brazil?
Offer a very short reply. 5.09. What is the difference between the highest and the second highest Domestic credit (% of GDP) of Gabon?
Your response must be concise. 0.21. What is the difference between the highest and the second highest Domestic credit (% of GDP) of St. Kitts and Nevis?
Ensure brevity in your answer.  2.99. What is the difference between the highest and the second highest Domestic credit (% of GDP) in Vanuatu?
Your response must be concise. 10.21. What is the difference between the highest and the lowest Domestic credit (% of GDP) in Brazil?
Keep it short and to the point. 18.16. What is the difference between the highest and the lowest Domestic credit (% of GDP) of Gabon?
Offer a terse response. 3.95. What is the difference between the highest and the lowest Domestic credit (% of GDP) in St. Kitts and Nevis?
Offer a terse response. 7.48. What is the difference between the highest and the lowest Domestic credit (% of GDP) in Vanuatu?
Offer a terse response. 20.38. 